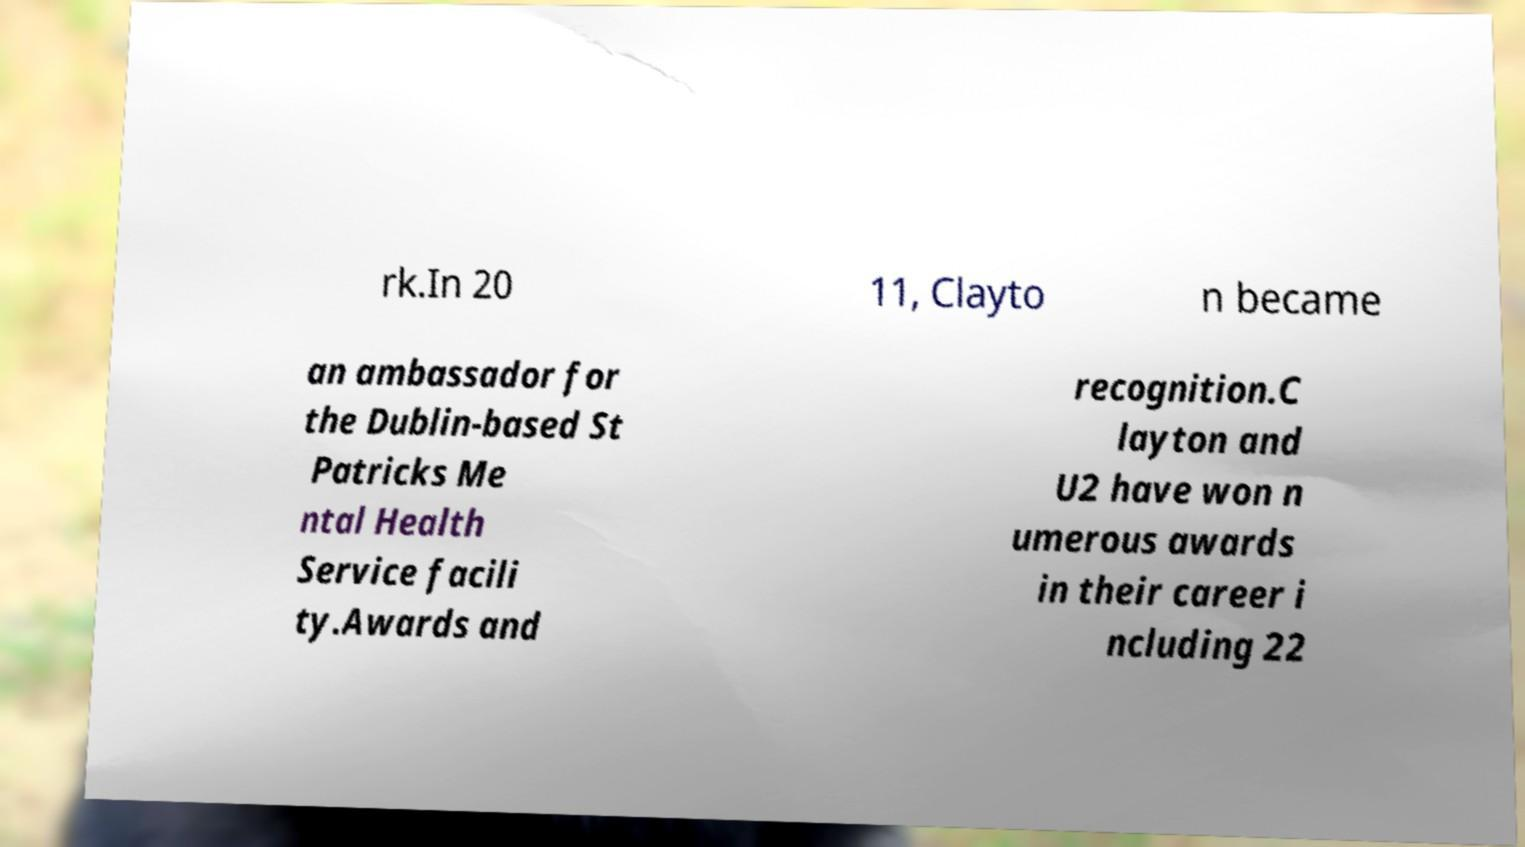Can you read and provide the text displayed in the image?This photo seems to have some interesting text. Can you extract and type it out for me? rk.In 20 11, Clayto n became an ambassador for the Dublin-based St Patricks Me ntal Health Service facili ty.Awards and recognition.C layton and U2 have won n umerous awards in their career i ncluding 22 